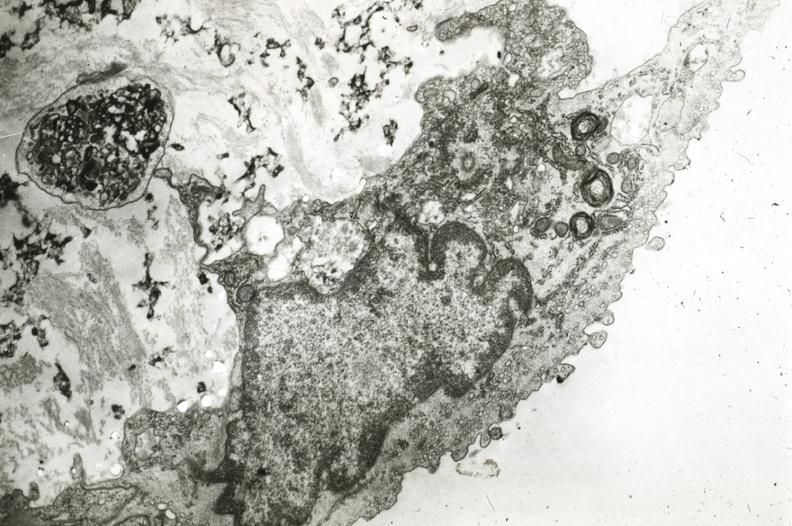how does this image show endothelium?
Answer the question using a single word or phrase. With myelin bodies precipitated lipid in interstitial space 